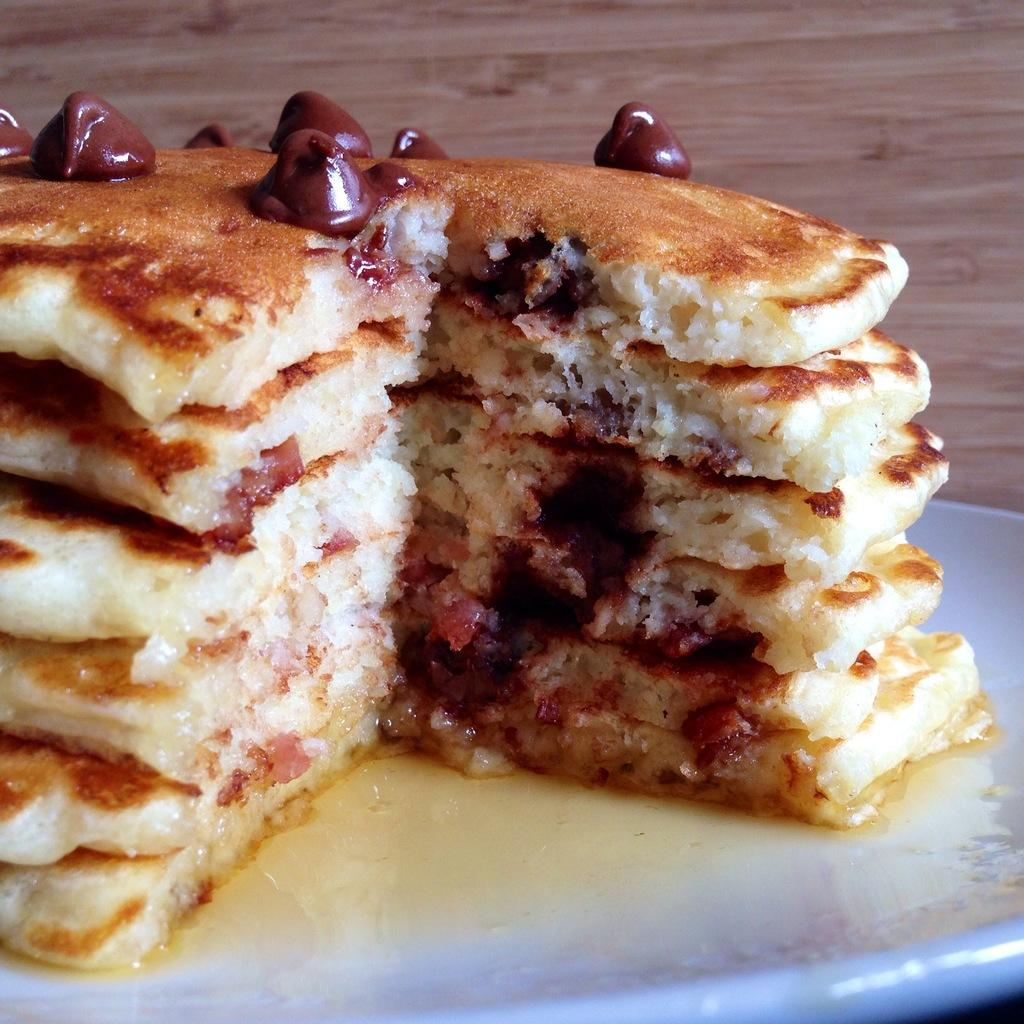What type of food is on the plate in the image? There are pancakes on a plate in the image. What color is the plate? The plate is white. What type of surface can be seen in the background of the image? There is a wooden surface visible in the background of the image. What is the range of the wing in the image? There is no wing present in the image, so it is not possible to determine its range. 